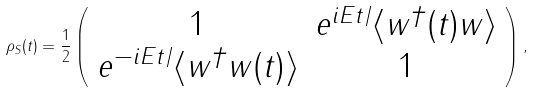Convert formula to latex. <formula><loc_0><loc_0><loc_500><loc_500>\rho _ { S } ( t ) = \frac { 1 } { 2 } \left ( \begin{array} { c c } 1 & e ^ { i E t / } \langle w ^ { \dagger } ( t ) w \rangle \\ e ^ { - i E t / } \langle w ^ { \dagger } w ( t ) \rangle & 1 \end{array} \right ) ,</formula> 